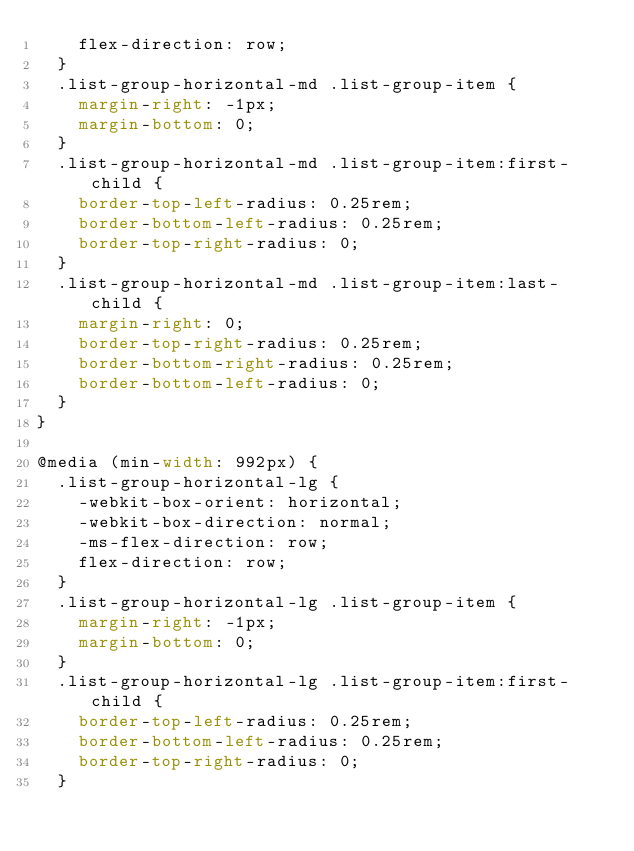<code> <loc_0><loc_0><loc_500><loc_500><_CSS_>    flex-direction: row;
  }
  .list-group-horizontal-md .list-group-item {
    margin-right: -1px;
    margin-bottom: 0;
  }
  .list-group-horizontal-md .list-group-item:first-child {
    border-top-left-radius: 0.25rem;
    border-bottom-left-radius: 0.25rem;
    border-top-right-radius: 0;
  }
  .list-group-horizontal-md .list-group-item:last-child {
    margin-right: 0;
    border-top-right-radius: 0.25rem;
    border-bottom-right-radius: 0.25rem;
    border-bottom-left-radius: 0;
  }
}

@media (min-width: 992px) {
  .list-group-horizontal-lg {
    -webkit-box-orient: horizontal;
    -webkit-box-direction: normal;
    -ms-flex-direction: row;
    flex-direction: row;
  }
  .list-group-horizontal-lg .list-group-item {
    margin-right: -1px;
    margin-bottom: 0;
  }
  .list-group-horizontal-lg .list-group-item:first-child {
    border-top-left-radius: 0.25rem;
    border-bottom-left-radius: 0.25rem;
    border-top-right-radius: 0;
  }</code> 